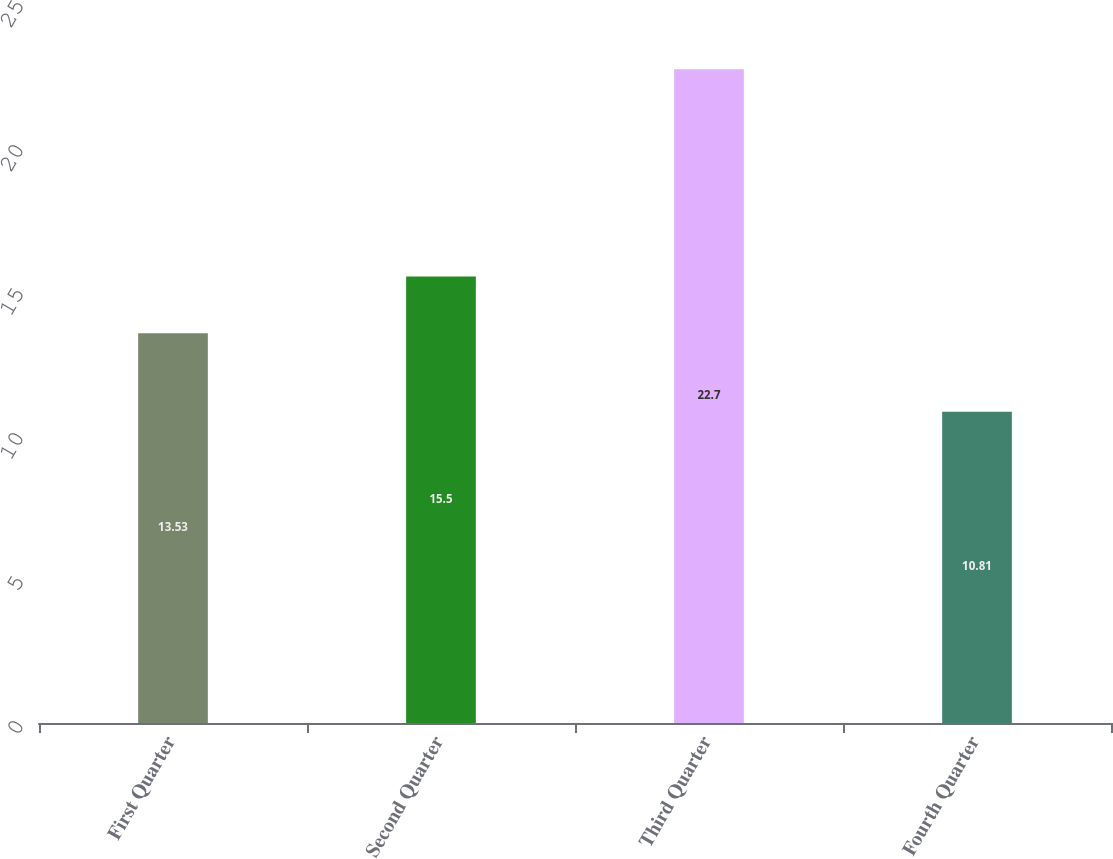Convert chart. <chart><loc_0><loc_0><loc_500><loc_500><bar_chart><fcel>First Quarter<fcel>Second Quarter<fcel>Third Quarter<fcel>Fourth Quarter<nl><fcel>13.53<fcel>15.5<fcel>22.7<fcel>10.81<nl></chart> 